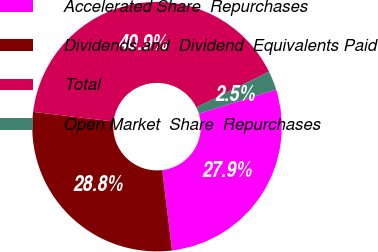Convert chart to OTSL. <chart><loc_0><loc_0><loc_500><loc_500><pie_chart><fcel>Accelerated Share  Repurchases<fcel>Dividends and  Dividend  Equivalents Paid<fcel>Total<fcel>Open Market  Share  Repurchases<nl><fcel>27.88%<fcel>28.8%<fcel>40.86%<fcel>2.46%<nl></chart> 